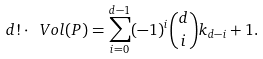Convert formula to latex. <formula><loc_0><loc_0><loc_500><loc_500>d ! \cdot \ V o l ( P ) = \sum _ { i = 0 } ^ { d - 1 } ( - 1 ) ^ { i } \binom { d } { i } k _ { d - i } + 1 .</formula> 